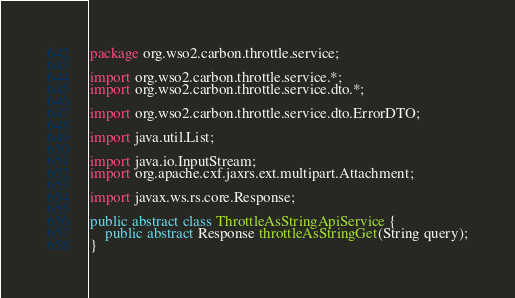<code> <loc_0><loc_0><loc_500><loc_500><_Java_>package org.wso2.carbon.throttle.service;

import org.wso2.carbon.throttle.service.*;
import org.wso2.carbon.throttle.service.dto.*;

import org.wso2.carbon.throttle.service.dto.ErrorDTO;

import java.util.List;

import java.io.InputStream;
import org.apache.cxf.jaxrs.ext.multipart.Attachment;

import javax.ws.rs.core.Response;

public abstract class ThrottleAsStringApiService {
    public abstract Response throttleAsStringGet(String query);
}

</code> 